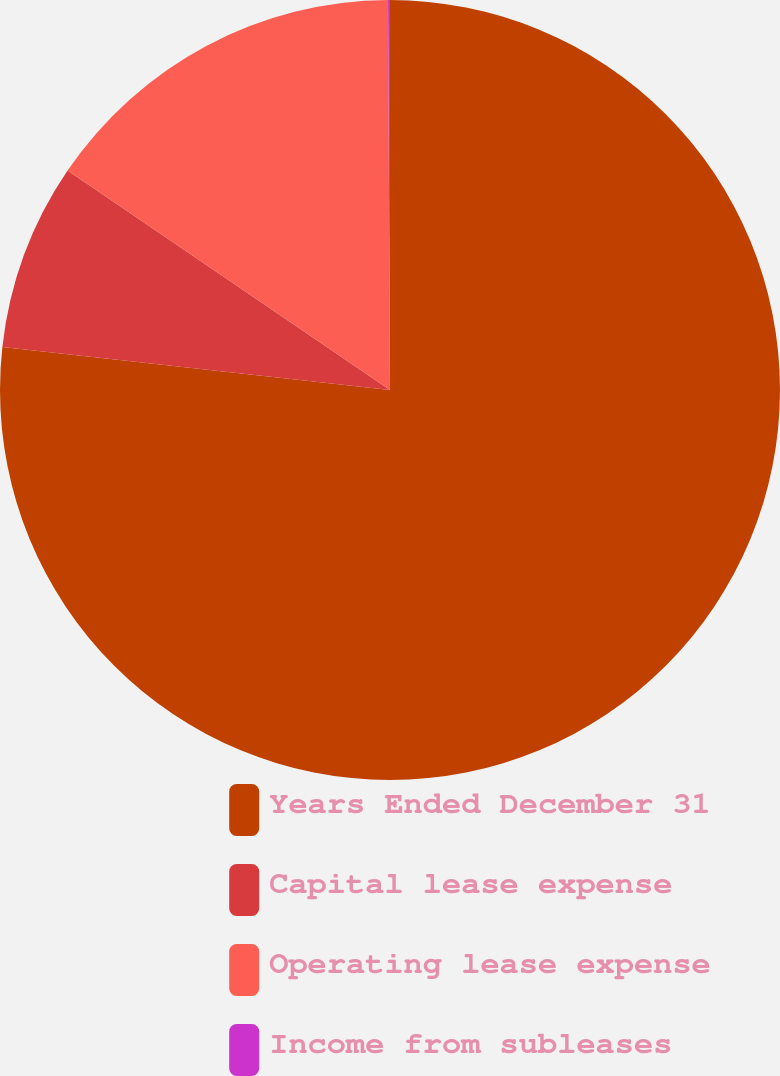<chart> <loc_0><loc_0><loc_500><loc_500><pie_chart><fcel>Years Ended December 31<fcel>Capital lease expense<fcel>Operating lease expense<fcel>Income from subleases<nl><fcel>76.76%<fcel>7.75%<fcel>15.41%<fcel>0.08%<nl></chart> 